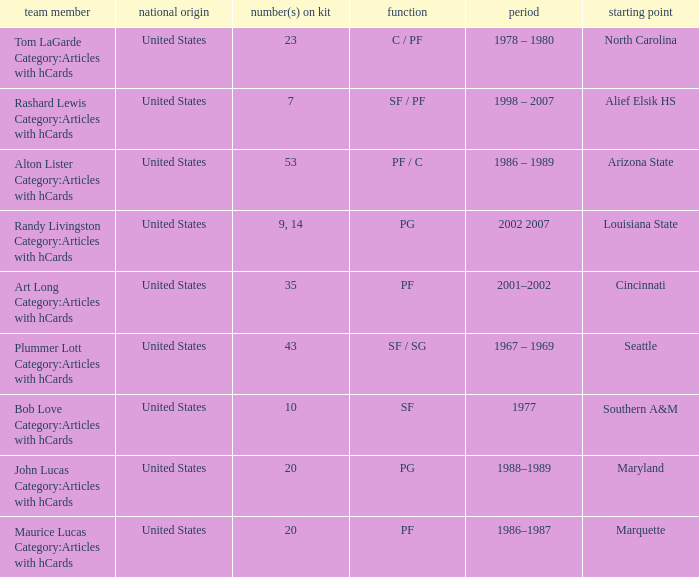Alton Lister Category:Articles with hCards has what as the listed years? 1986 – 1989. Could you help me parse every detail presented in this table? {'header': ['team member', 'national origin', 'number(s) on kit', 'function', 'period', 'starting point'], 'rows': [['Tom LaGarde Category:Articles with hCards', 'United States', '23', 'C / PF', '1978 – 1980', 'North Carolina'], ['Rashard Lewis Category:Articles with hCards', 'United States', '7', 'SF / PF', '1998 – 2007', 'Alief Elsik HS'], ['Alton Lister Category:Articles with hCards', 'United States', '53', 'PF / C', '1986 – 1989', 'Arizona State'], ['Randy Livingston Category:Articles with hCards', 'United States', '9, 14', 'PG', '2002 2007', 'Louisiana State'], ['Art Long Category:Articles with hCards', 'United States', '35', 'PF', '2001–2002', 'Cincinnati'], ['Plummer Lott Category:Articles with hCards', 'United States', '43', 'SF / SG', '1967 – 1969', 'Seattle'], ['Bob Love Category:Articles with hCards', 'United States', '10', 'SF', '1977', 'Southern A&M'], ['John Lucas Category:Articles with hCards', 'United States', '20', 'PG', '1988–1989', 'Maryland'], ['Maurice Lucas Category:Articles with hCards', 'United States', '20', 'PF', '1986–1987', 'Marquette']]} 